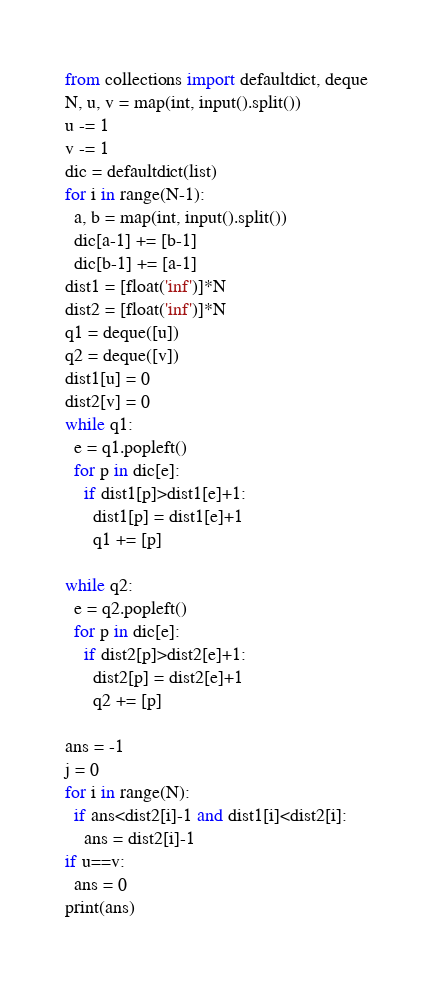Convert code to text. <code><loc_0><loc_0><loc_500><loc_500><_Python_>from collections import defaultdict, deque
N, u, v = map(int, input().split())
u -= 1
v -= 1
dic = defaultdict(list)
for i in range(N-1):
  a, b = map(int, input().split())
  dic[a-1] += [b-1]
  dic[b-1] += [a-1]
dist1 = [float('inf')]*N
dist2 = [float('inf')]*N
q1 = deque([u])
q2 = deque([v])
dist1[u] = 0
dist2[v] = 0
while q1:
  e = q1.popleft()
  for p in dic[e]:
    if dist1[p]>dist1[e]+1:
      dist1[p] = dist1[e]+1
      q1 += [p]

while q2:
  e = q2.popleft()
  for p in dic[e]:
    if dist2[p]>dist2[e]+1:
      dist2[p] = dist2[e]+1
      q2 += [p]

ans = -1
j = 0
for i in range(N):
  if ans<dist2[i]-1 and dist1[i]<dist2[i]:
    ans = dist2[i]-1
if u==v:
  ans = 0
print(ans)</code> 